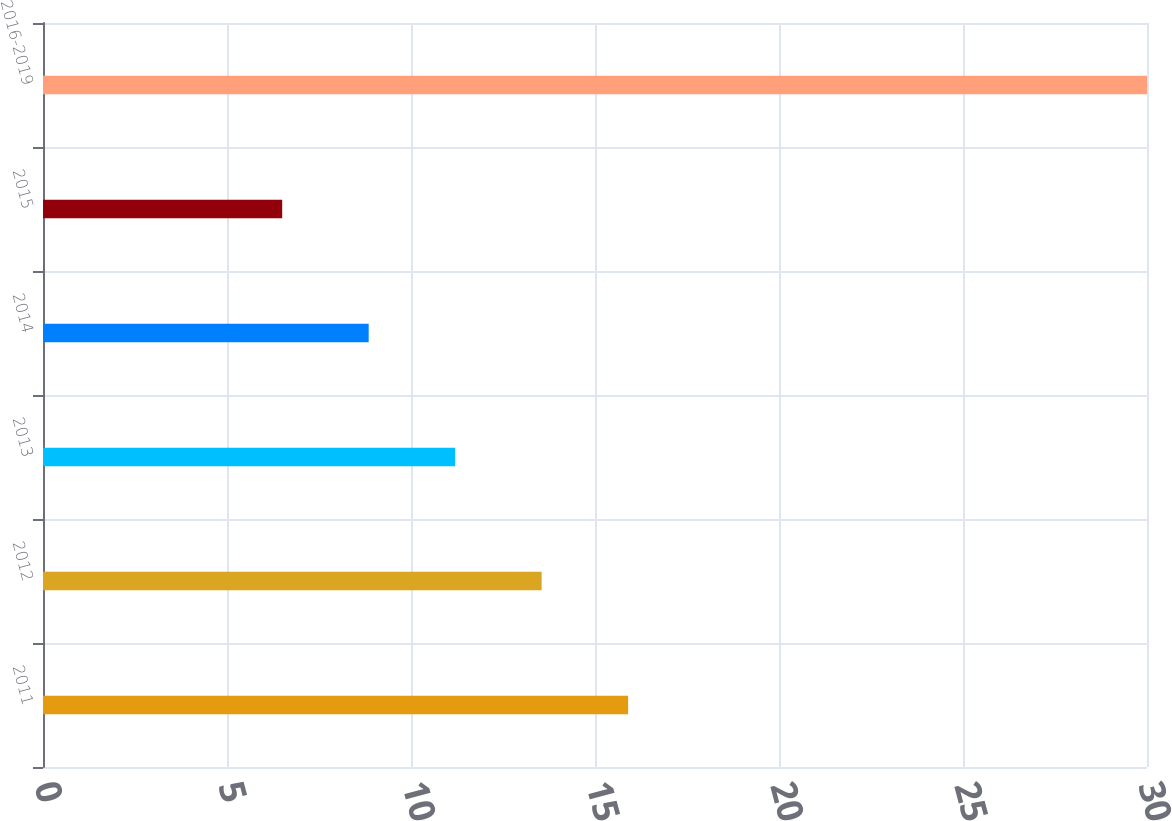<chart> <loc_0><loc_0><loc_500><loc_500><bar_chart><fcel>2011<fcel>2012<fcel>2013<fcel>2014<fcel>2015<fcel>2016-2019<nl><fcel>15.9<fcel>13.55<fcel>11.2<fcel>8.85<fcel>6.5<fcel>30<nl></chart> 